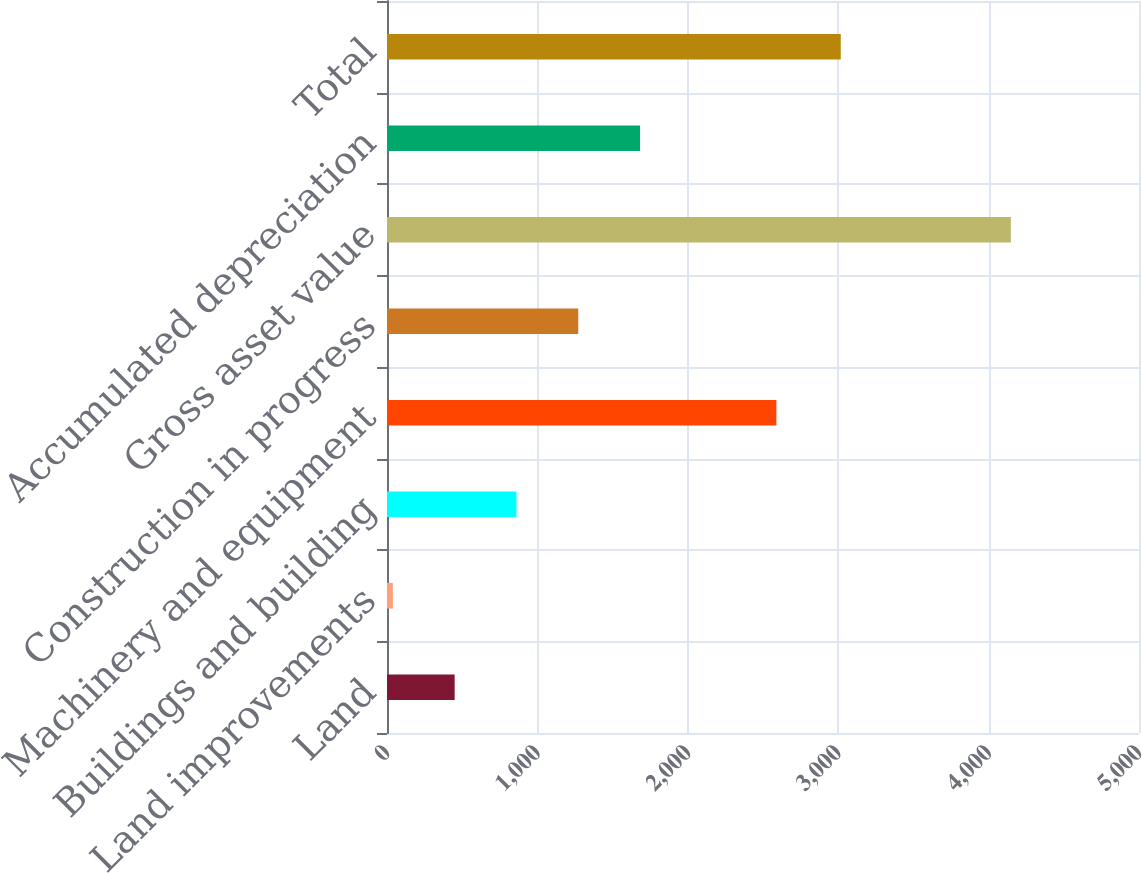Convert chart to OTSL. <chart><loc_0><loc_0><loc_500><loc_500><bar_chart><fcel>Land<fcel>Land improvements<fcel>Buildings and building<fcel>Machinery and equipment<fcel>Construction in progress<fcel>Gross asset value<fcel>Accumulated depreciation<fcel>Total<nl><fcel>449.9<fcel>39<fcel>860.8<fcel>2589<fcel>1271.7<fcel>4148<fcel>1682.6<fcel>3017<nl></chart> 